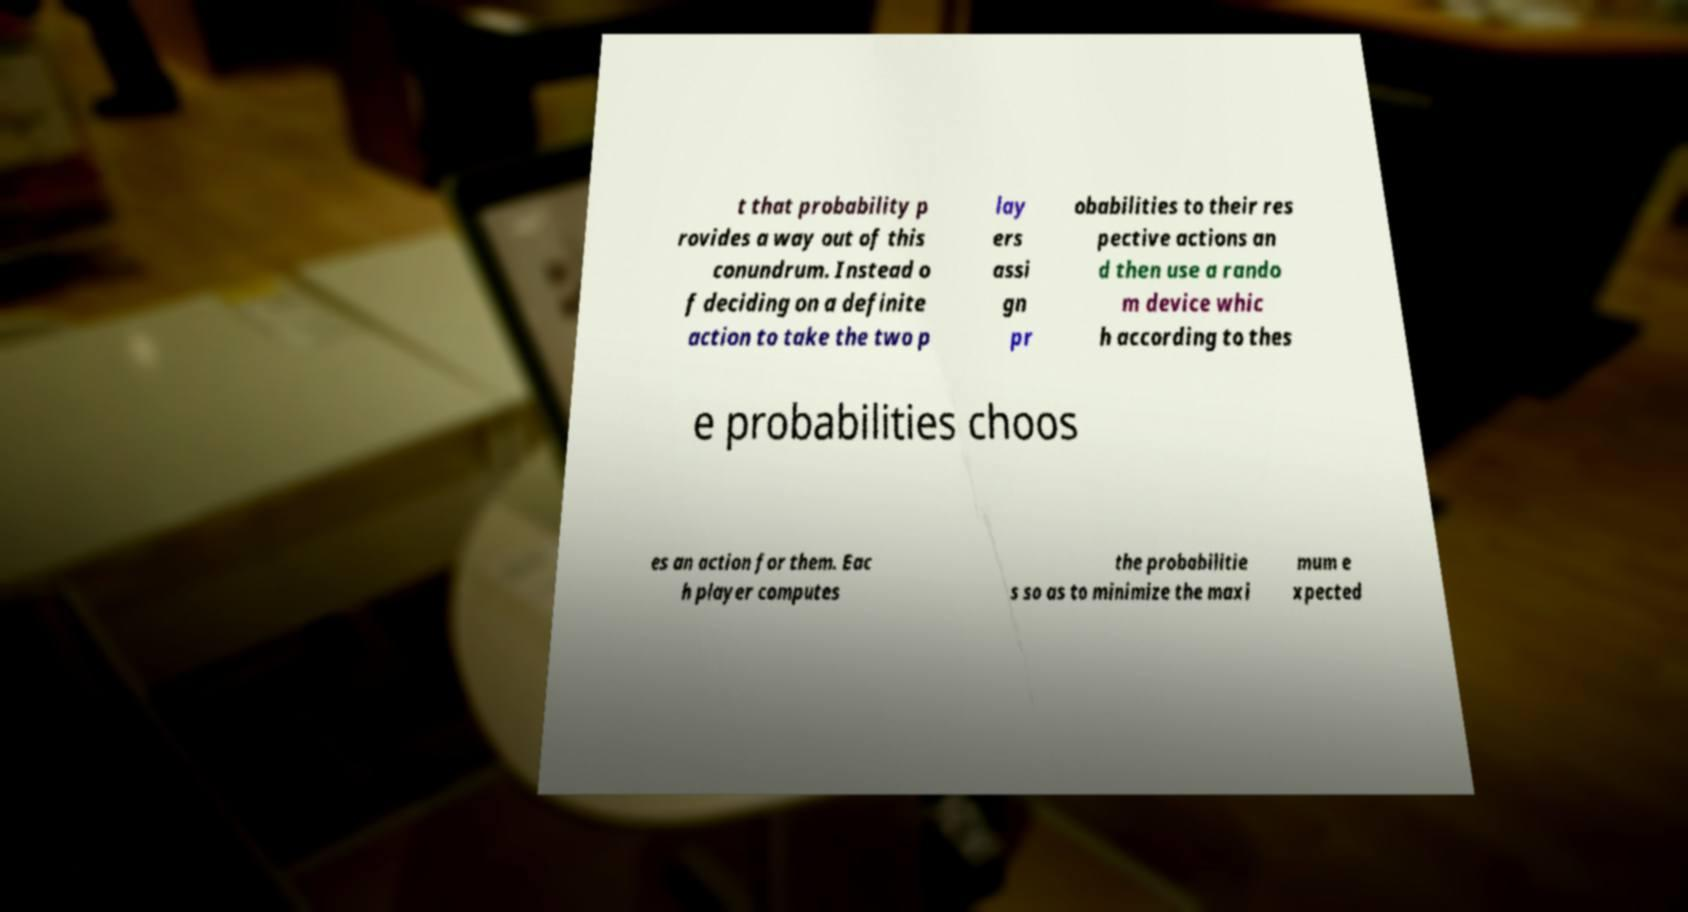Please identify and transcribe the text found in this image. t that probability p rovides a way out of this conundrum. Instead o f deciding on a definite action to take the two p lay ers assi gn pr obabilities to their res pective actions an d then use a rando m device whic h according to thes e probabilities choos es an action for them. Eac h player computes the probabilitie s so as to minimize the maxi mum e xpected 